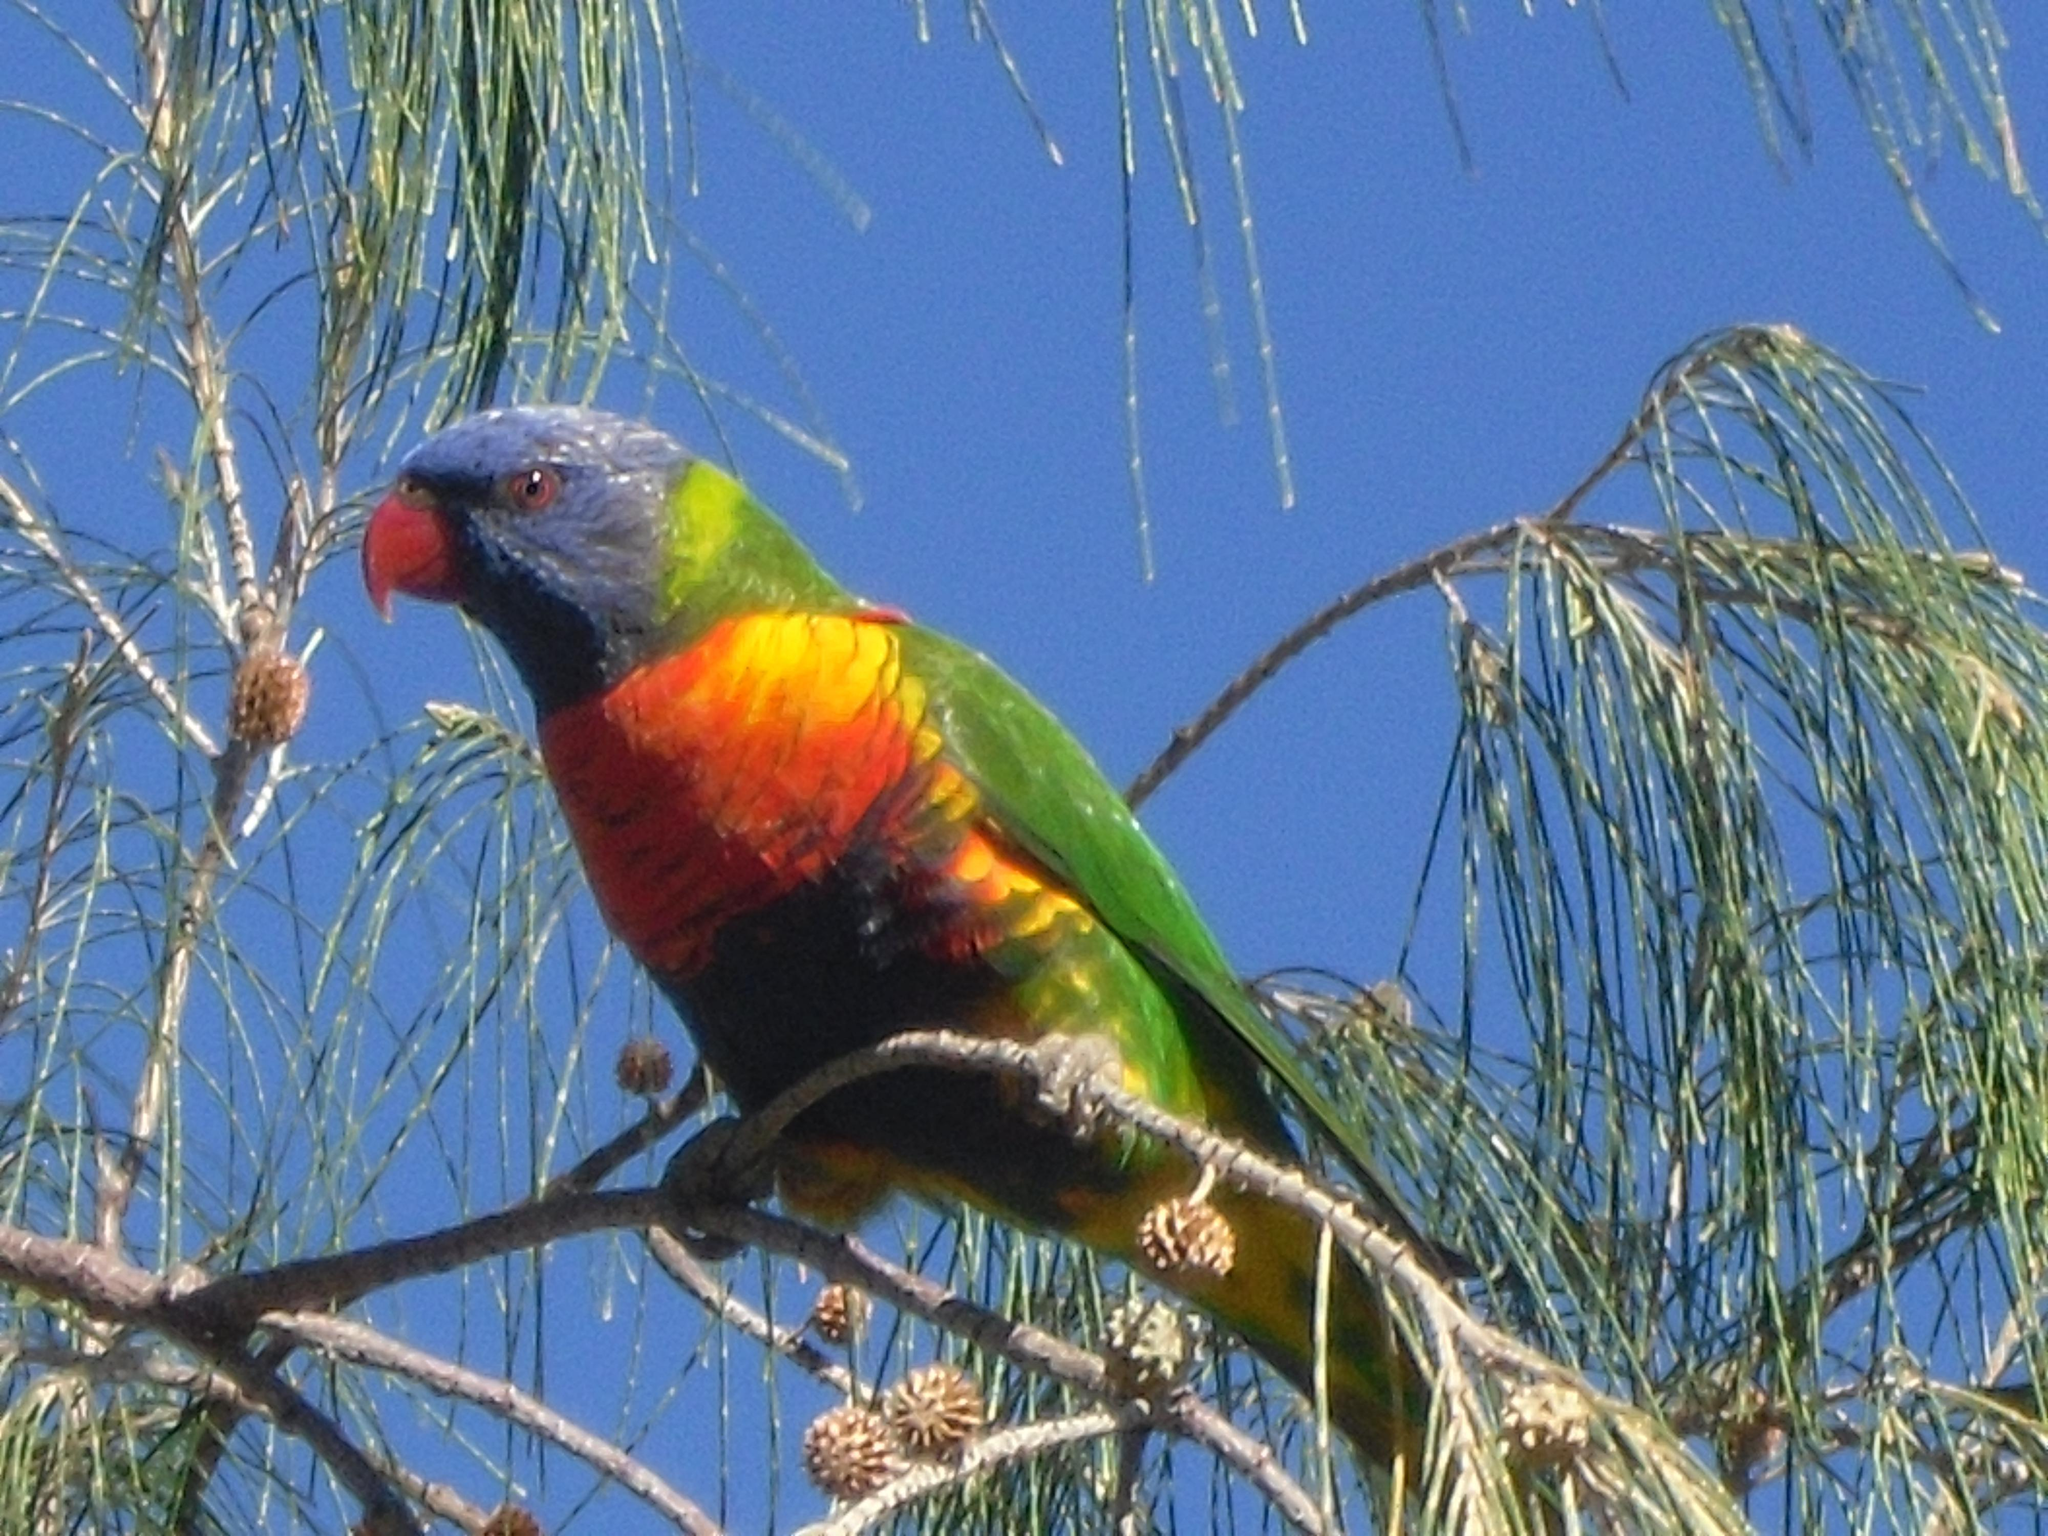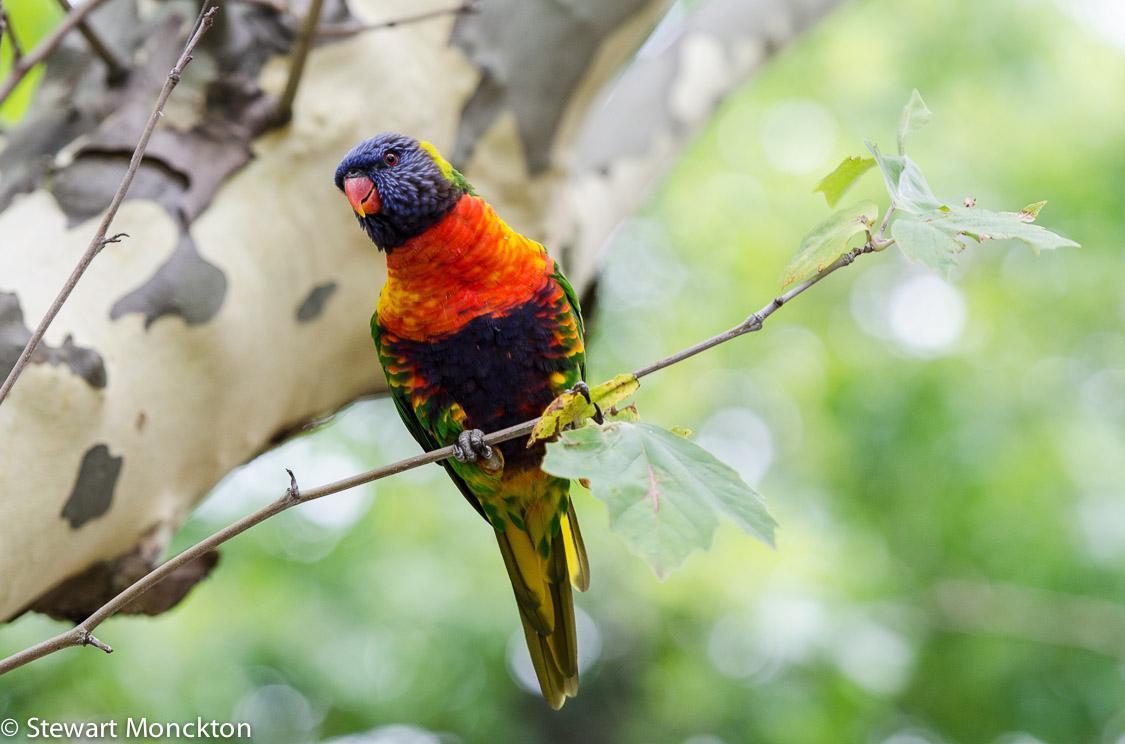The first image is the image on the left, the second image is the image on the right. For the images shown, is this caption "There are two birds" true? Answer yes or no. Yes. 